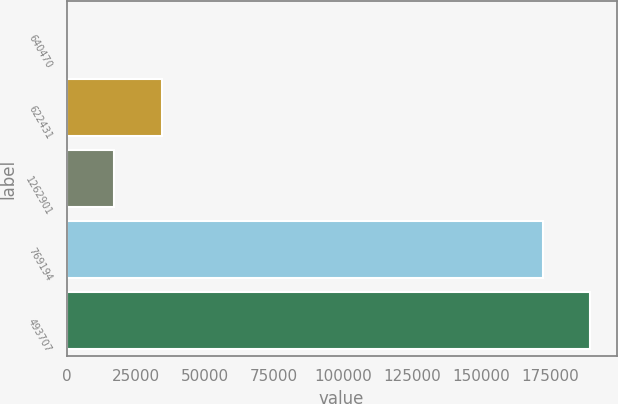Convert chart to OTSL. <chart><loc_0><loc_0><loc_500><loc_500><bar_chart><fcel>640470<fcel>622431<fcel>1262901<fcel>769194<fcel>493707<nl><fcel>4<fcel>34500<fcel>17252<fcel>172286<fcel>189534<nl></chart> 